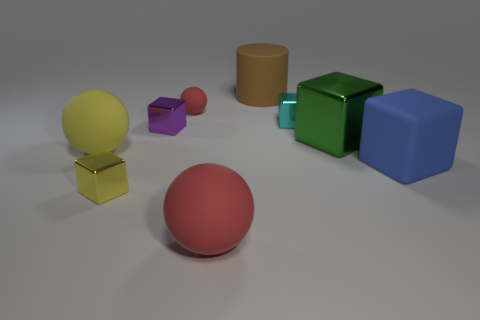Add 1 yellow shiny cubes. How many objects exist? 10 Subtract all yellow rubber spheres. How many spheres are left? 2 Subtract all green blocks. How many red spheres are left? 2 Subtract all green blocks. How many blocks are left? 4 Subtract all cylinders. How many objects are left? 8 Subtract 1 spheres. How many spheres are left? 2 Subtract 0 cyan cylinders. How many objects are left? 9 Subtract all blue cubes. Subtract all cyan cylinders. How many cubes are left? 4 Subtract all tiny purple things. Subtract all red balls. How many objects are left? 6 Add 1 large yellow objects. How many large yellow objects are left? 2 